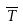<formula> <loc_0><loc_0><loc_500><loc_500>\overline { T }</formula> 